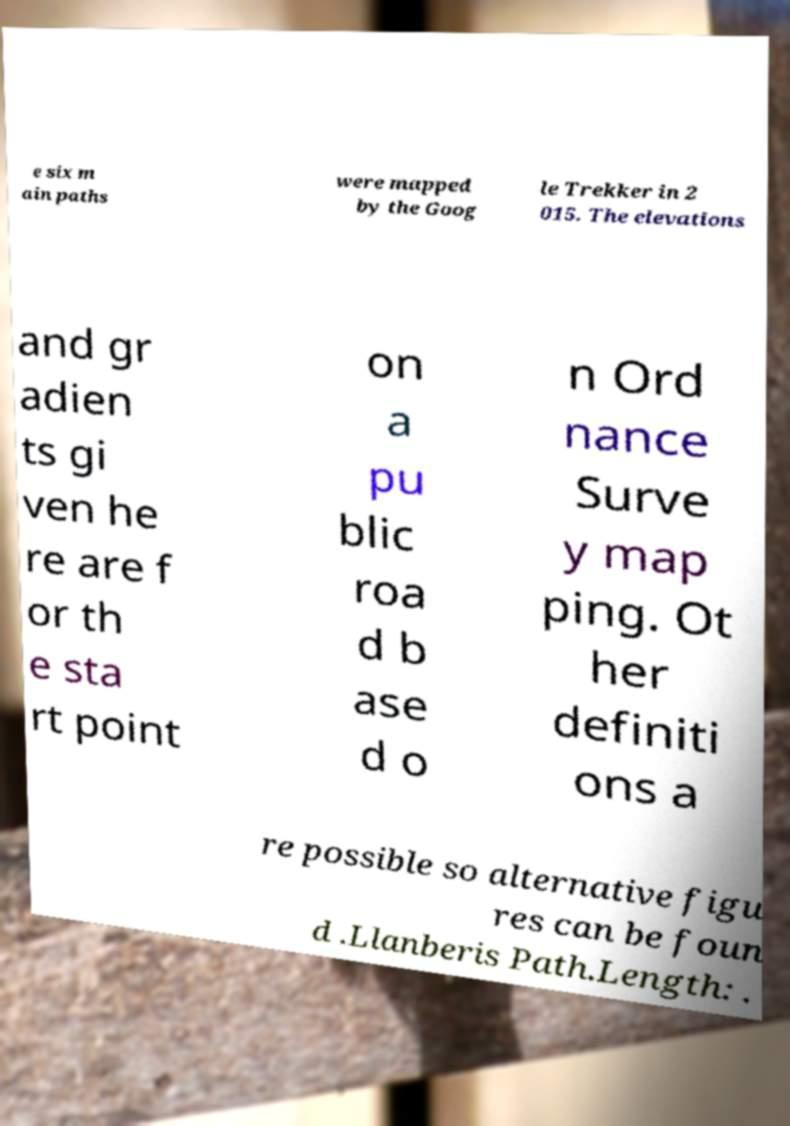Can you read and provide the text displayed in the image?This photo seems to have some interesting text. Can you extract and type it out for me? e six m ain paths were mapped by the Goog le Trekker in 2 015. The elevations and gr adien ts gi ven he re are f or th e sta rt point on a pu blic roa d b ase d o n Ord nance Surve y map ping. Ot her definiti ons a re possible so alternative figu res can be foun d .Llanberis Path.Length: . 